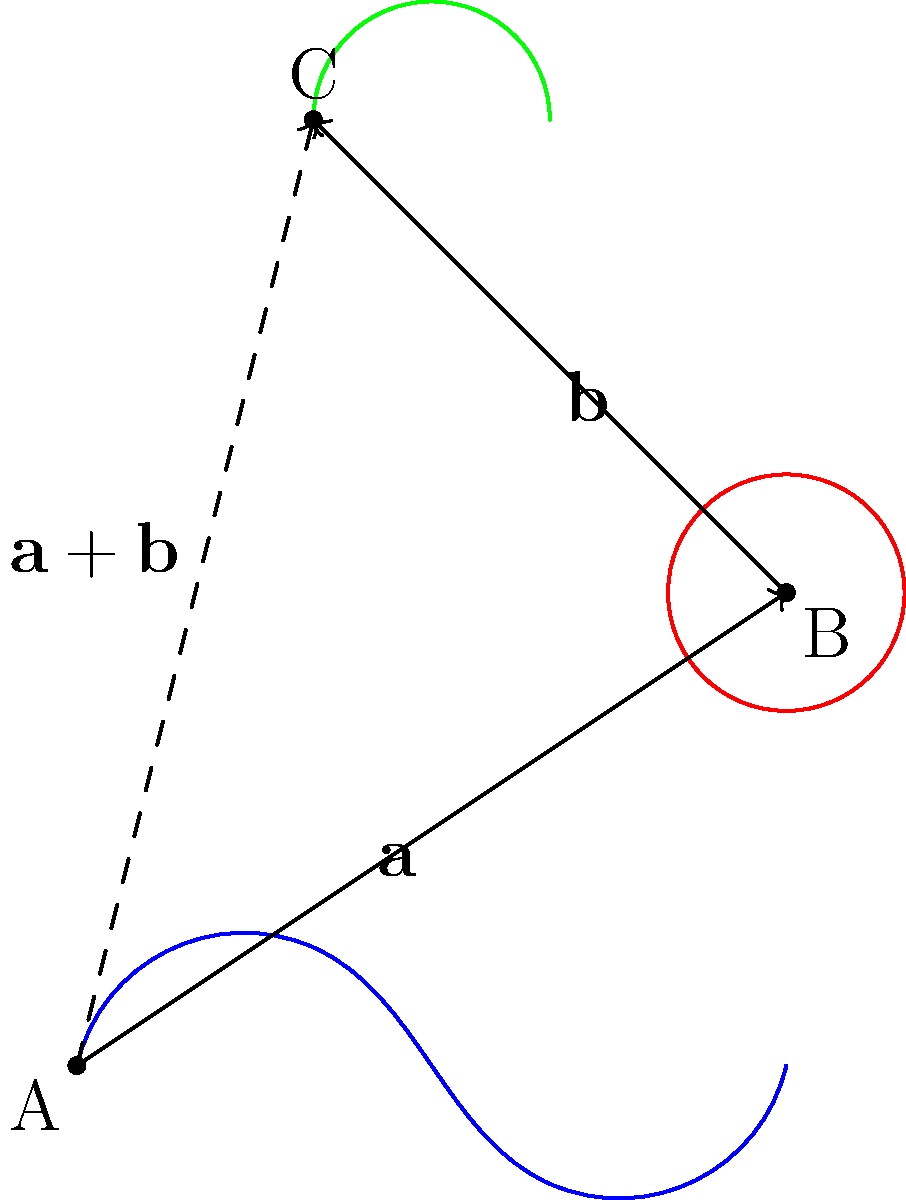In this surrealist-inspired vector addition scenario, we have three vectors represented by iconic Dalí-esque elements: a melting clock ($\mathbf{a}$), an eye ($\mathbf{b}$), and a mustache ($\mathbf{a} + \mathbf{b}$). Given that vector $\mathbf{a}$ extends from point A (0,0) to B (3,2), and vector $\mathbf{b}$ extends from B to C (1,4), what are the components of the resultant vector $\mathbf{a} + \mathbf{b}$? To find the components of the resultant vector $\mathbf{a} + \mathbf{b}$, we'll follow these steps:

1. Identify the components of vector $\mathbf{a}$:
   $\mathbf{a} = (3-0, 2-0) = (3, 2)$

2. Identify the components of vector $\mathbf{b}$:
   $\mathbf{b} = (1-3, 4-2) = (-2, 2)$

3. Add the components of $\mathbf{a}$ and $\mathbf{b}$:
   $\mathbf{a} + \mathbf{b} = (3 + (-2), 2 + 2) = (1, 4)$

4. Verify the result visually:
   The resultant vector starts at point A (0,0) and ends at point C (1,4), which matches our calculation.

Thus, the components of the resultant vector $\mathbf{a} + \mathbf{b}$ are (1, 4).
Answer: $(1, 4)$ 